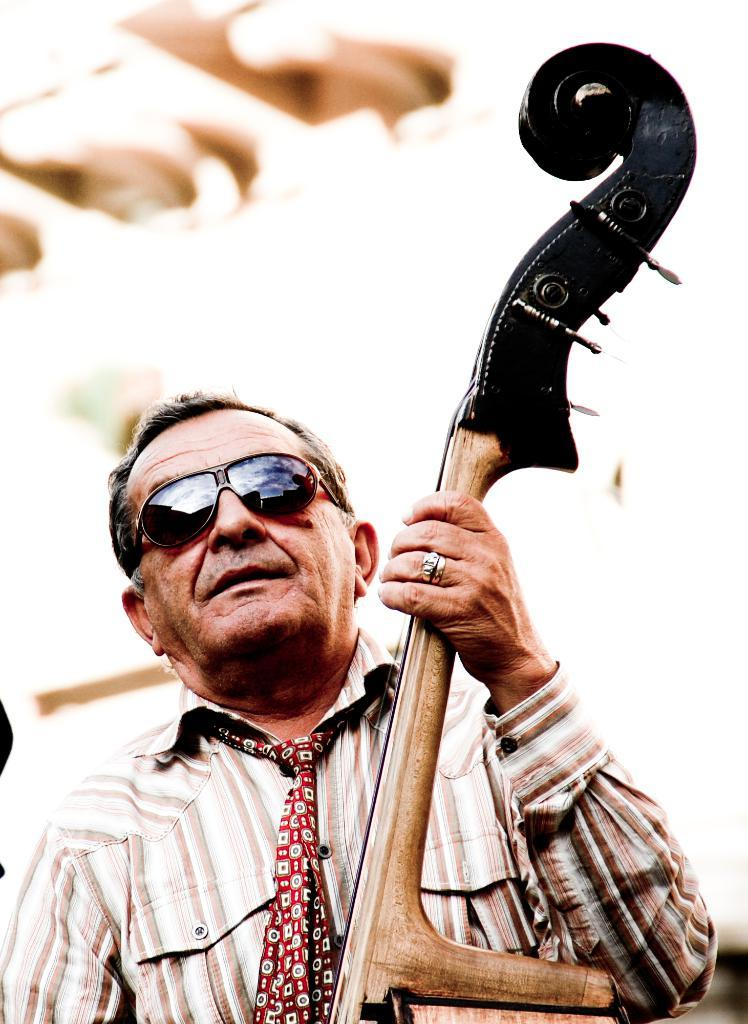What is the main subject of the image? The main subject of the image is an old man. What is the old man doing in the image? The old man is playing a music instrument. Can you describe the old man's clothing? The old man is wearing a cream and white color shirt. What accessory is the old man wearing in the image? The old man is wearing goggles. How is the background of the image depicted? The background of the man is blurred. What degree does the old man have in the image? There is no indication of the old man's educational background or degree in the image. Can you tell me how many cars are visible in the image? There are no cars present in the image; it features an old man playing a music instrument. 